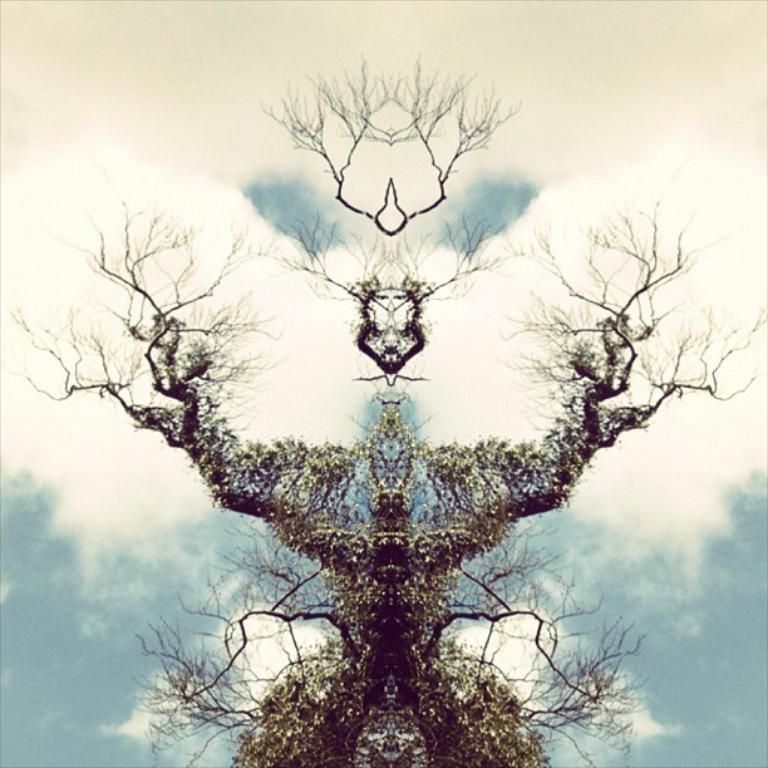What type of plant can be seen in the image? There is a tree in the image. What is visible in the background of the image? The sky is visible in the image. What can be observed in the sky? Clouds are present in the sky. Is there a railway visible in the image? No, there is no railway present in the image. What type of vegetable can be seen growing on the tree in the image? There are no vegetables present on the tree in the image. 